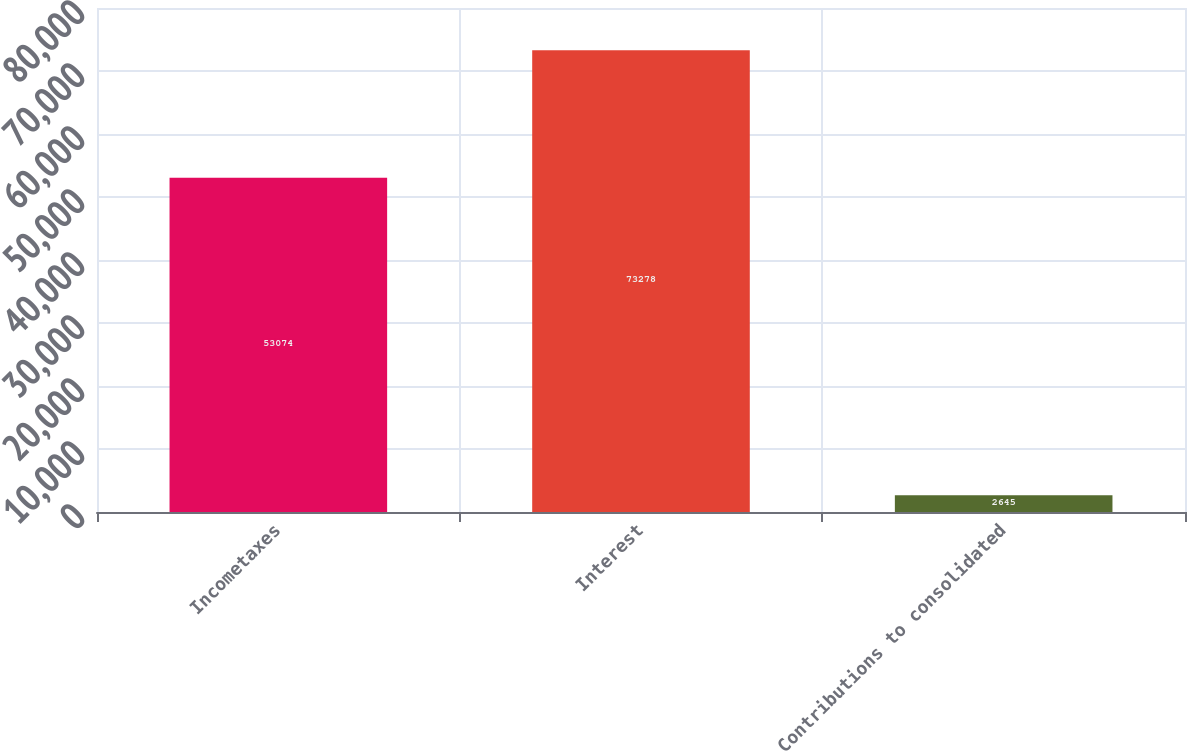Convert chart to OTSL. <chart><loc_0><loc_0><loc_500><loc_500><bar_chart><fcel>Incometaxes<fcel>Interest<fcel>Contributions to consolidated<nl><fcel>53074<fcel>73278<fcel>2645<nl></chart> 